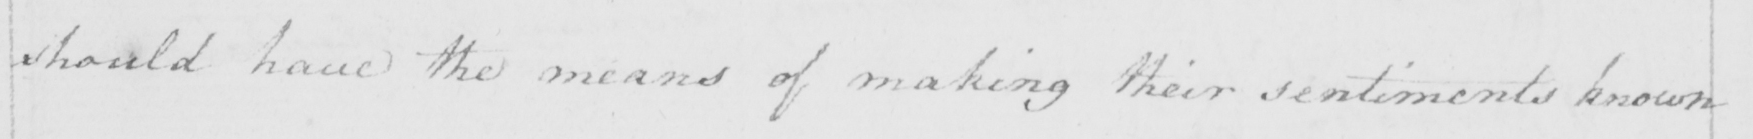Can you read and transcribe this handwriting? should have the means of making their sentiments known 